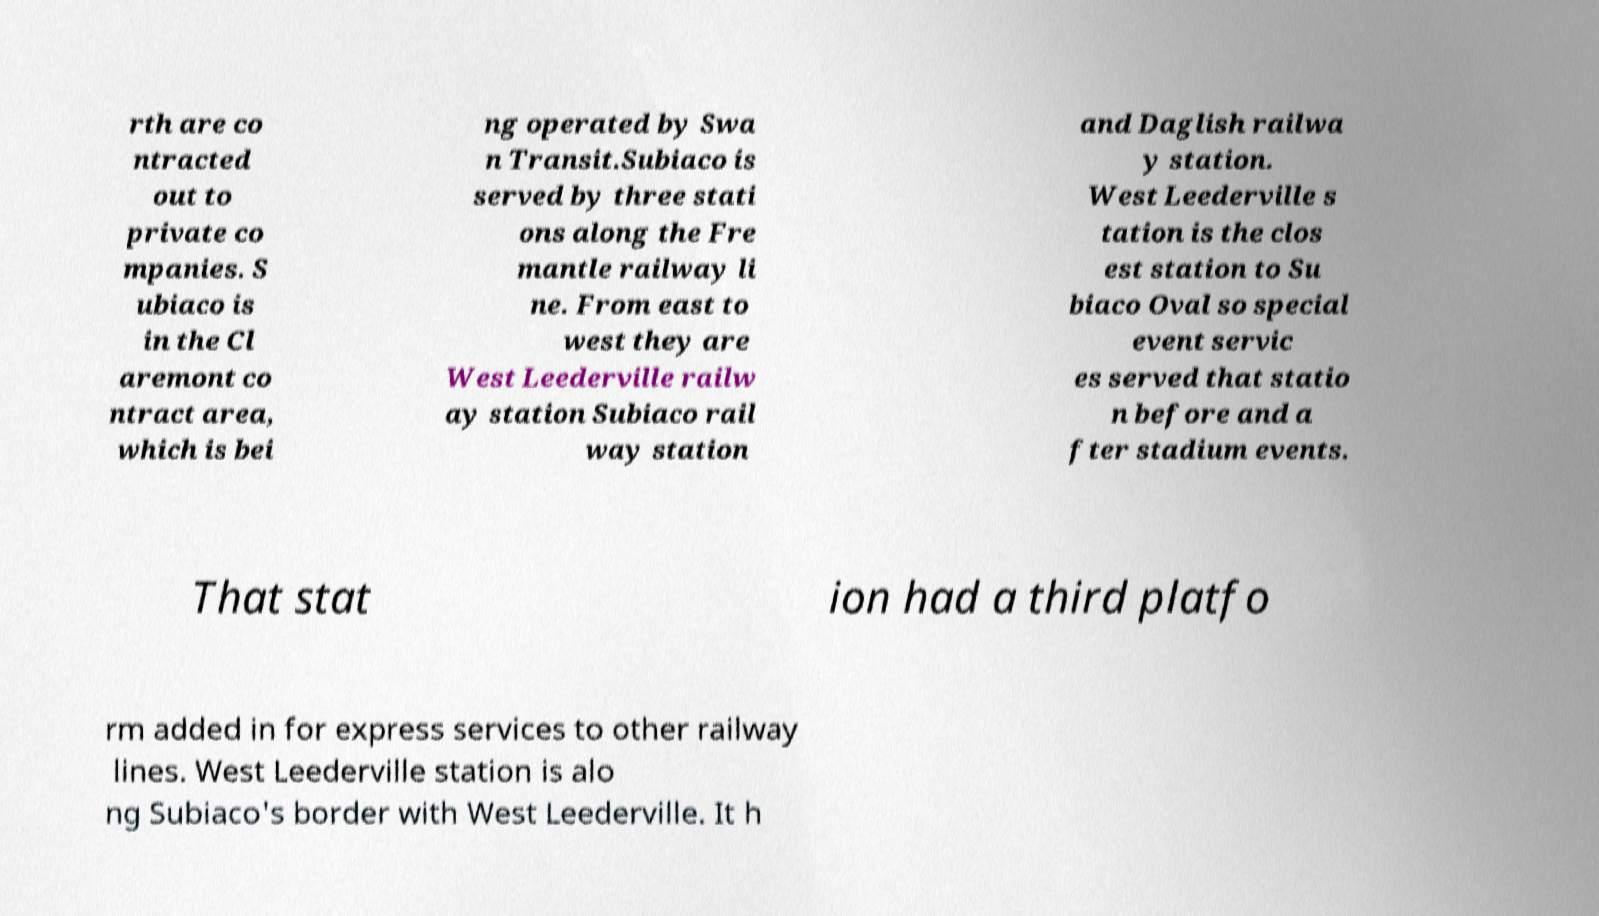Can you read and provide the text displayed in the image?This photo seems to have some interesting text. Can you extract and type it out for me? rth are co ntracted out to private co mpanies. S ubiaco is in the Cl aremont co ntract area, which is bei ng operated by Swa n Transit.Subiaco is served by three stati ons along the Fre mantle railway li ne. From east to west they are West Leederville railw ay station Subiaco rail way station and Daglish railwa y station. West Leederville s tation is the clos est station to Su biaco Oval so special event servic es served that statio n before and a fter stadium events. That stat ion had a third platfo rm added in for express services to other railway lines. West Leederville station is alo ng Subiaco's border with West Leederville. It h 